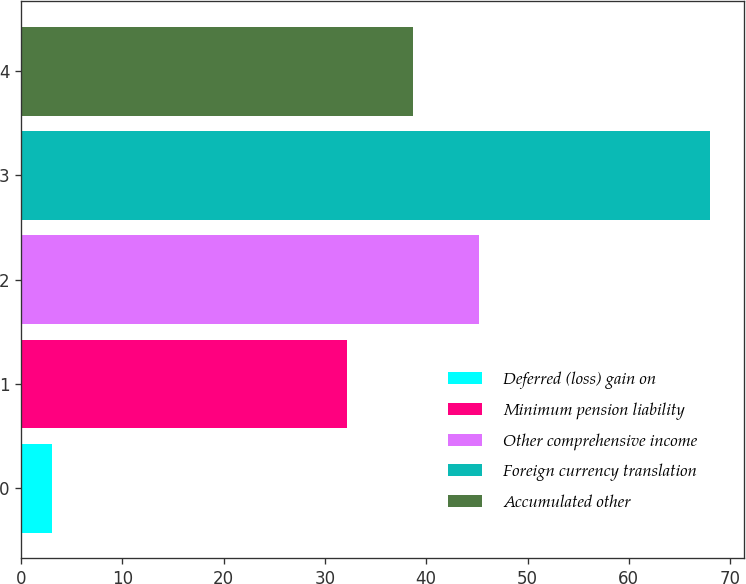Convert chart to OTSL. <chart><loc_0><loc_0><loc_500><loc_500><bar_chart><fcel>Deferred (loss) gain on<fcel>Minimum pension liability<fcel>Other comprehensive income<fcel>Foreign currency translation<fcel>Accumulated other<nl><fcel>3.1<fcel>32.2<fcel>45.18<fcel>68<fcel>38.69<nl></chart> 